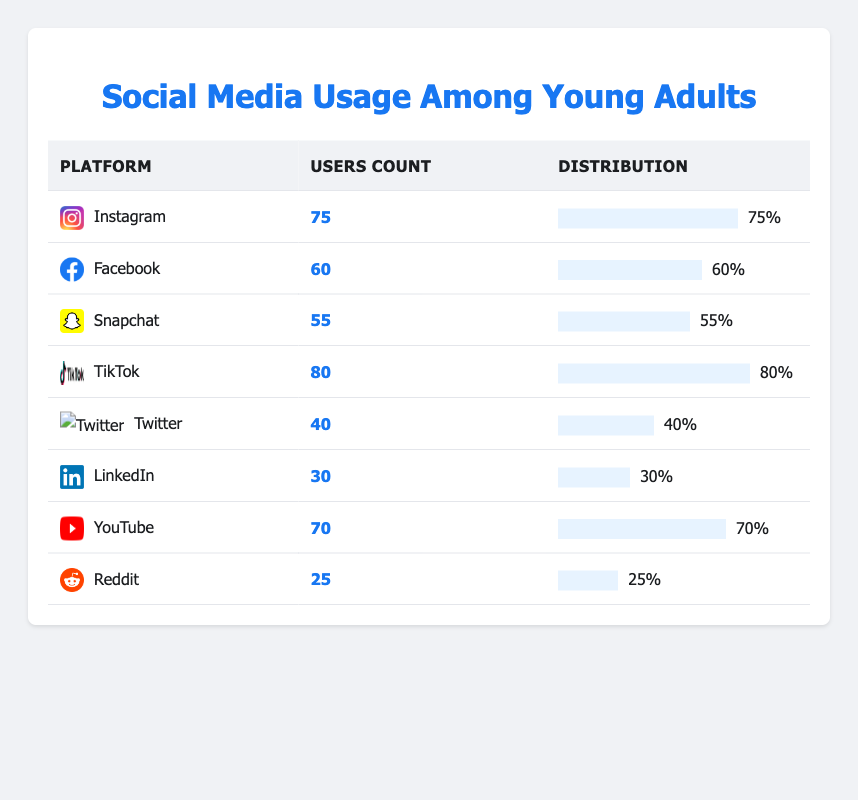What is the most popular social media platform among young adults? In the table, TikTok has the highest users count, which is 80. Therefore, it is the most popular platform among young adults.
Answer: TikTok How many users are there on Instagram? The table shows that Instagram has a users count of 75.
Answer: 75 What is the total number of users on Snapchat and Twitter combined? To find the total, we add the users count of Snapchat (55) to that of Twitter (40): 55 + 40 = 95.
Answer: 95 Is the number of users on LinkedIn greater than the number of users on Reddit? The users count for LinkedIn is 30, while for Reddit it is 25. Since 30 is greater than 25, the statement is true.
Answer: Yes What percentage of young adults use Facebook compared to TikTok? Facebook has 60 users, and TikTok has 80 users. The ratio is 60/80, which can be simplified to 0.75 or 75%.
Answer: 75% Which platform has a user count that is 10 more than Snapchat? Snapchat has a users count of 55. So, adding 10 gives us 55 + 10 = 65. The platform with 65 users is Facebook.
Answer: Facebook What is the average number of users across all the platforms listed? The total number of users is 75 + 60 + 55 + 80 + 40 + 30 + 70 + 25 = 435. There are 8 platforms, so the average is 435 / 8 = 54.375.
Answer: 54.375 Is TikTok used by more than half the number of users on YouTube? TikTok has 80 users, while YouTube has 70 users. Half of YouTube's users would be 35 (70 / 2). Since 80 is greater than 35, this statement is true.
Answer: Yes Which two platforms have the least number of combined users? The least users are on LinkedIn (30) and Reddit (25). Their combined users would be 30 + 25 = 55.
Answer: LinkedIn and Reddit 